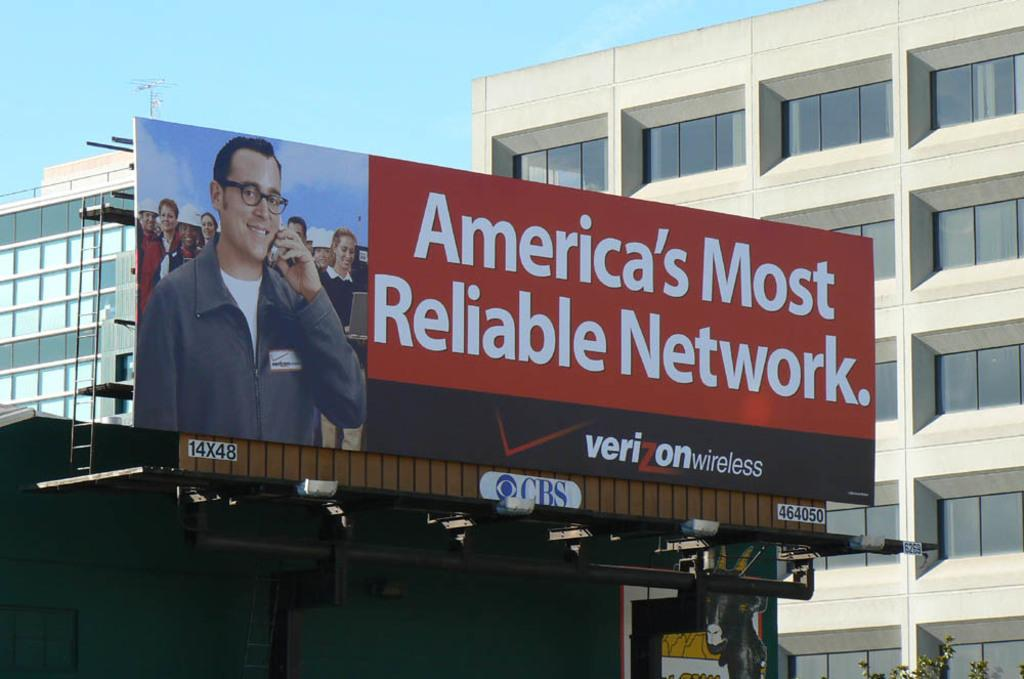<image>
Relay a brief, clear account of the picture shown. A billboard for Verizon states it's the most reliable network in America. 